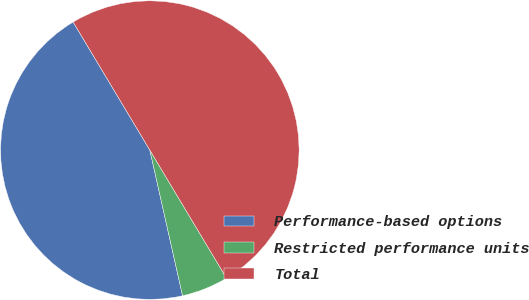<chart> <loc_0><loc_0><loc_500><loc_500><pie_chart><fcel>Performance-based options<fcel>Restricted performance units<fcel>Total<nl><fcel>44.93%<fcel>5.07%<fcel>50.0%<nl></chart> 